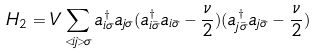Convert formula to latex. <formula><loc_0><loc_0><loc_500><loc_500>H _ { 2 } = V \sum _ { < i j > \sigma } a _ { i \sigma } ^ { \dagger } a _ { j \sigma } ( a _ { i \bar { \sigma } } ^ { \dagger } a _ { i \bar { \sigma } } - \frac { \nu } { 2 } ) ( a _ { j \bar { \sigma } } ^ { \dagger } a _ { j \bar { \sigma } } - \frac { \nu } { 2 } )</formula> 